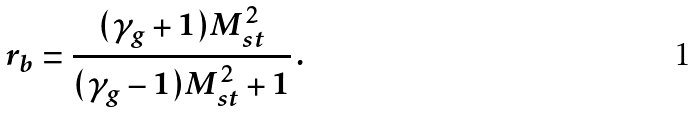Convert formula to latex. <formula><loc_0><loc_0><loc_500><loc_500>r _ { b } = \frac { ( \gamma _ { g } + 1 ) M _ { s t } ^ { 2 } } { ( \gamma _ { g } - 1 ) M _ { s t } ^ { 2 } + 1 } \, .</formula> 